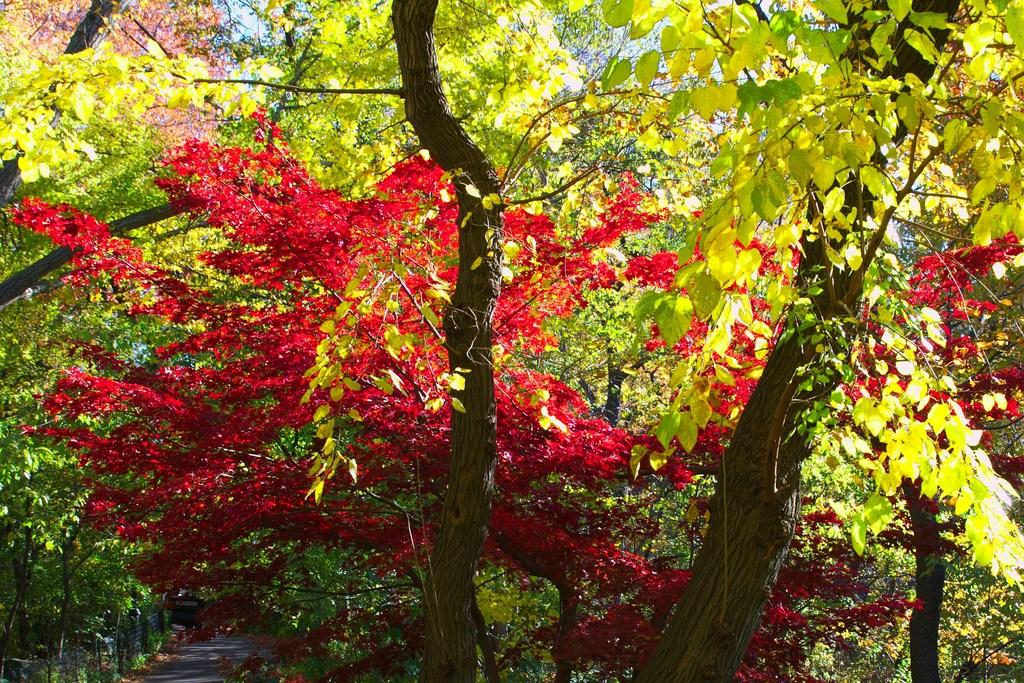What type of vegetation can be seen in the image? There are trees in the image. What can be found in the image that might be used for walking? There is a path in the image that can be used for walking. What is present in the image that might serve as a boundary or barrier? There is a fence in the image that might serve as a boundary or barrier. What is visible in the background of the image? The sky is visible in the background of the image. How many men are holding corks in the image? There are no men or corks present in the image. What causes the fence to burst in the image? There is no fence bursting in the image; the fence is intact. 